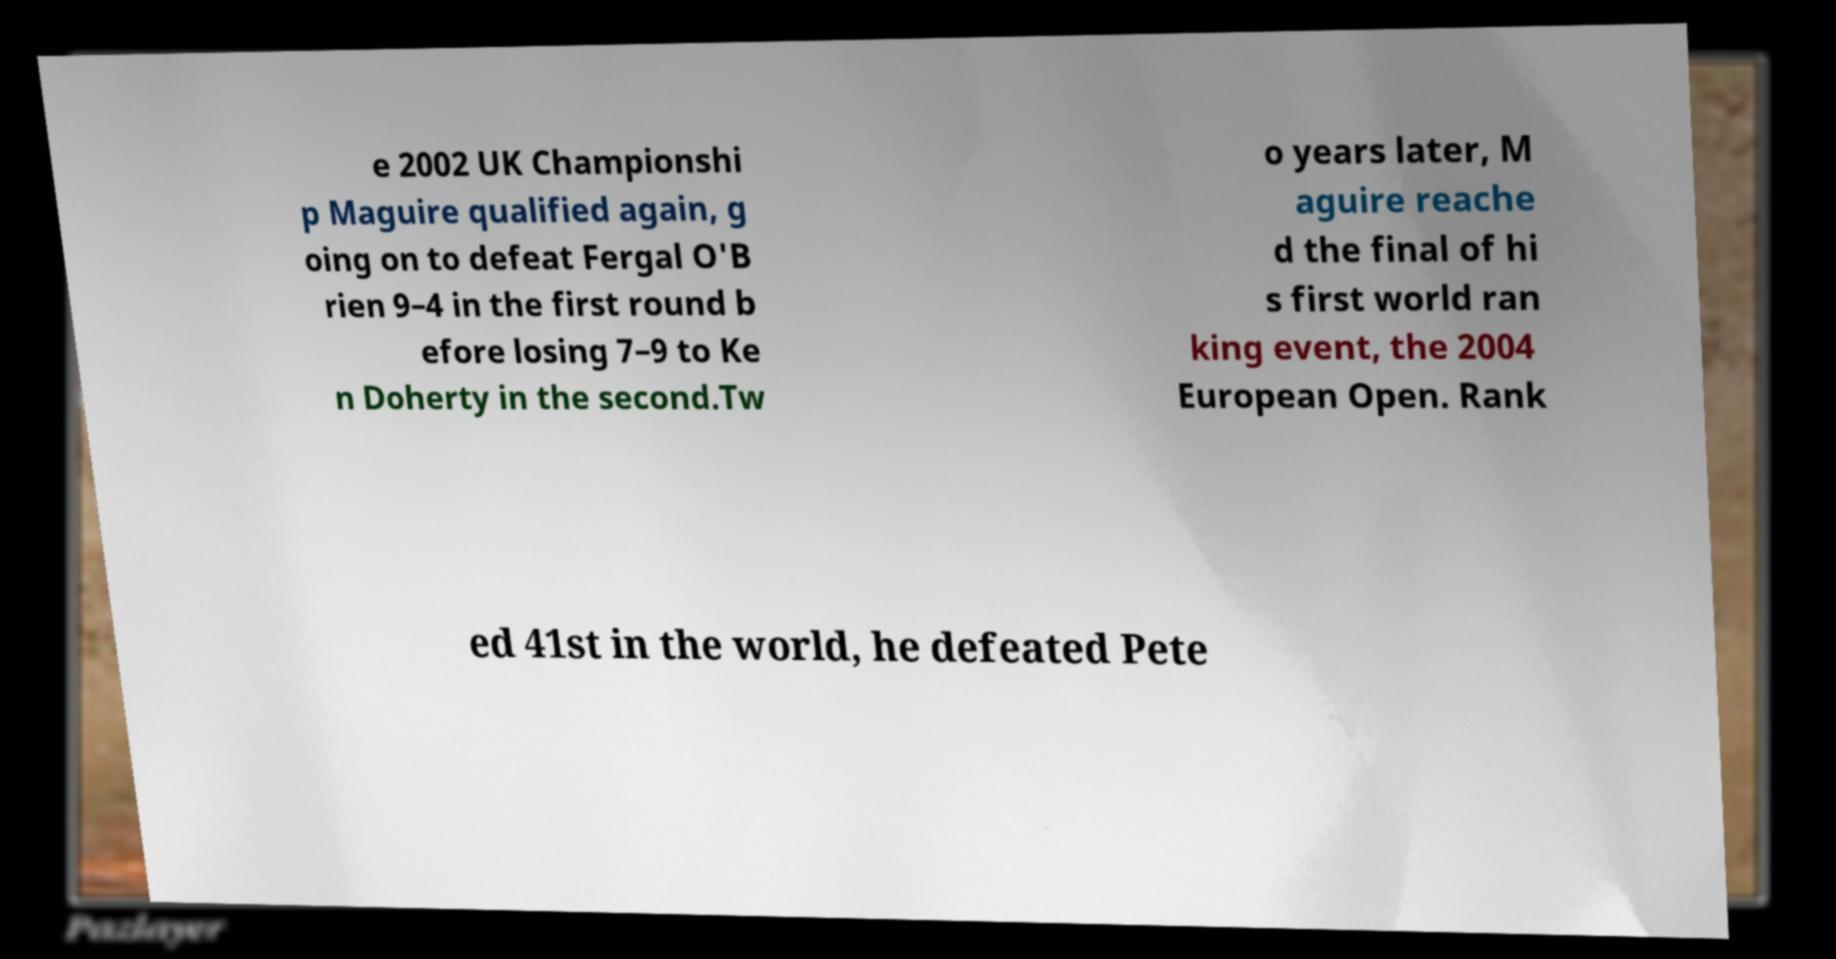What messages or text are displayed in this image? I need them in a readable, typed format. e 2002 UK Championshi p Maguire qualified again, g oing on to defeat Fergal O'B rien 9–4 in the first round b efore losing 7–9 to Ke n Doherty in the second.Tw o years later, M aguire reache d the final of hi s first world ran king event, the 2004 European Open. Rank ed 41st in the world, he defeated Pete 